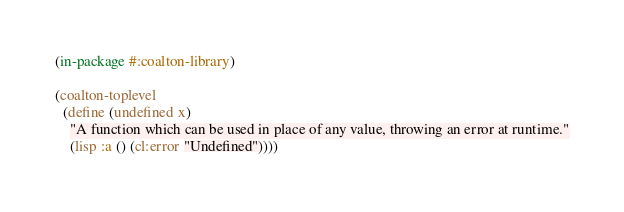Convert code to text. <code><loc_0><loc_0><loc_500><loc_500><_Lisp_>(in-package #:coalton-library)

(coalton-toplevel
  (define (undefined x)
    "A function which can be used in place of any value, throwing an error at runtime."
    (lisp :a () (cl:error "Undefined"))))
</code> 